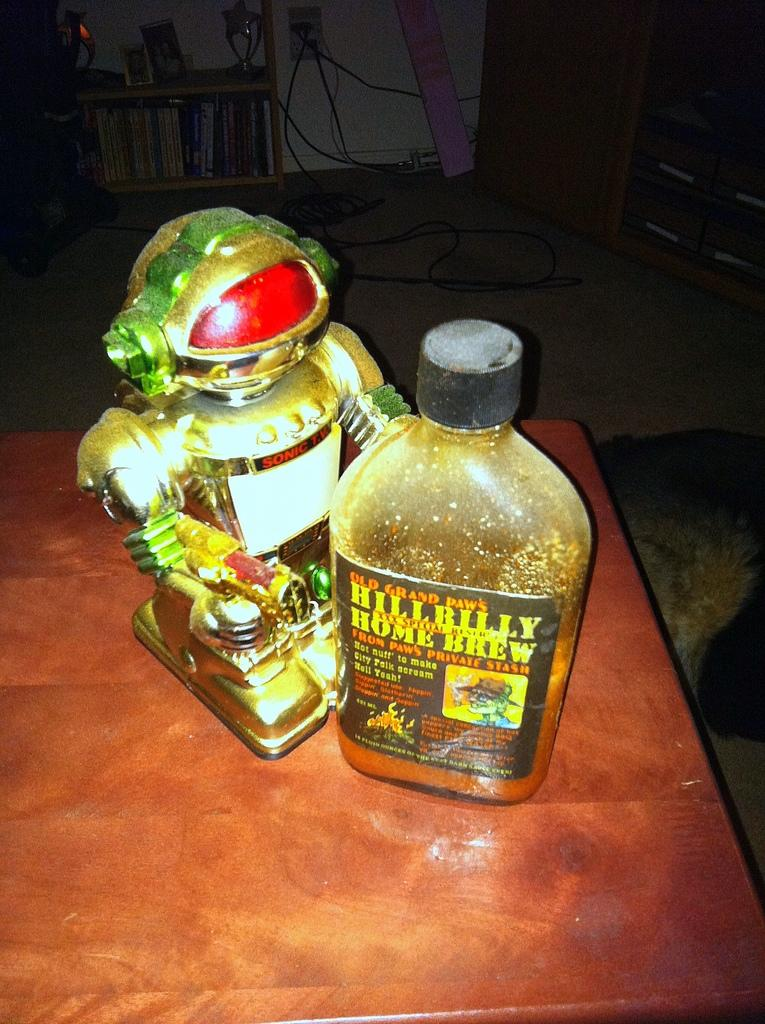<image>
Write a terse but informative summary of the picture. A bottle of Old Grand Paw's Hillbilly Home Brew sitting on a table 